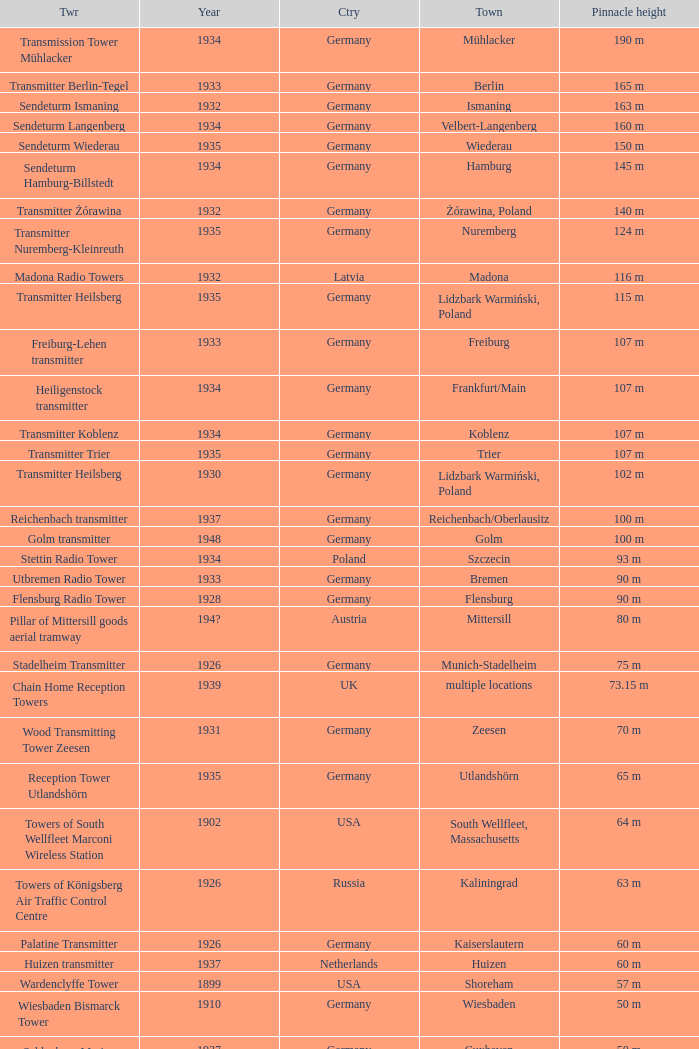Which country had a tower destroyed in 1899? USA. 